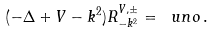Convert formula to latex. <formula><loc_0><loc_0><loc_500><loc_500>( - \Delta + V - k ^ { 2 } ) R ^ { V , \pm } _ { - k ^ { 2 } } = \ u n o \, .</formula> 